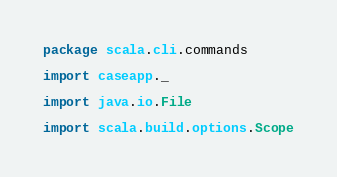Convert code to text. <code><loc_0><loc_0><loc_500><loc_500><_Scala_>package scala.cli.commands

import caseapp._

import java.io.File

import scala.build.options.Scope</code> 